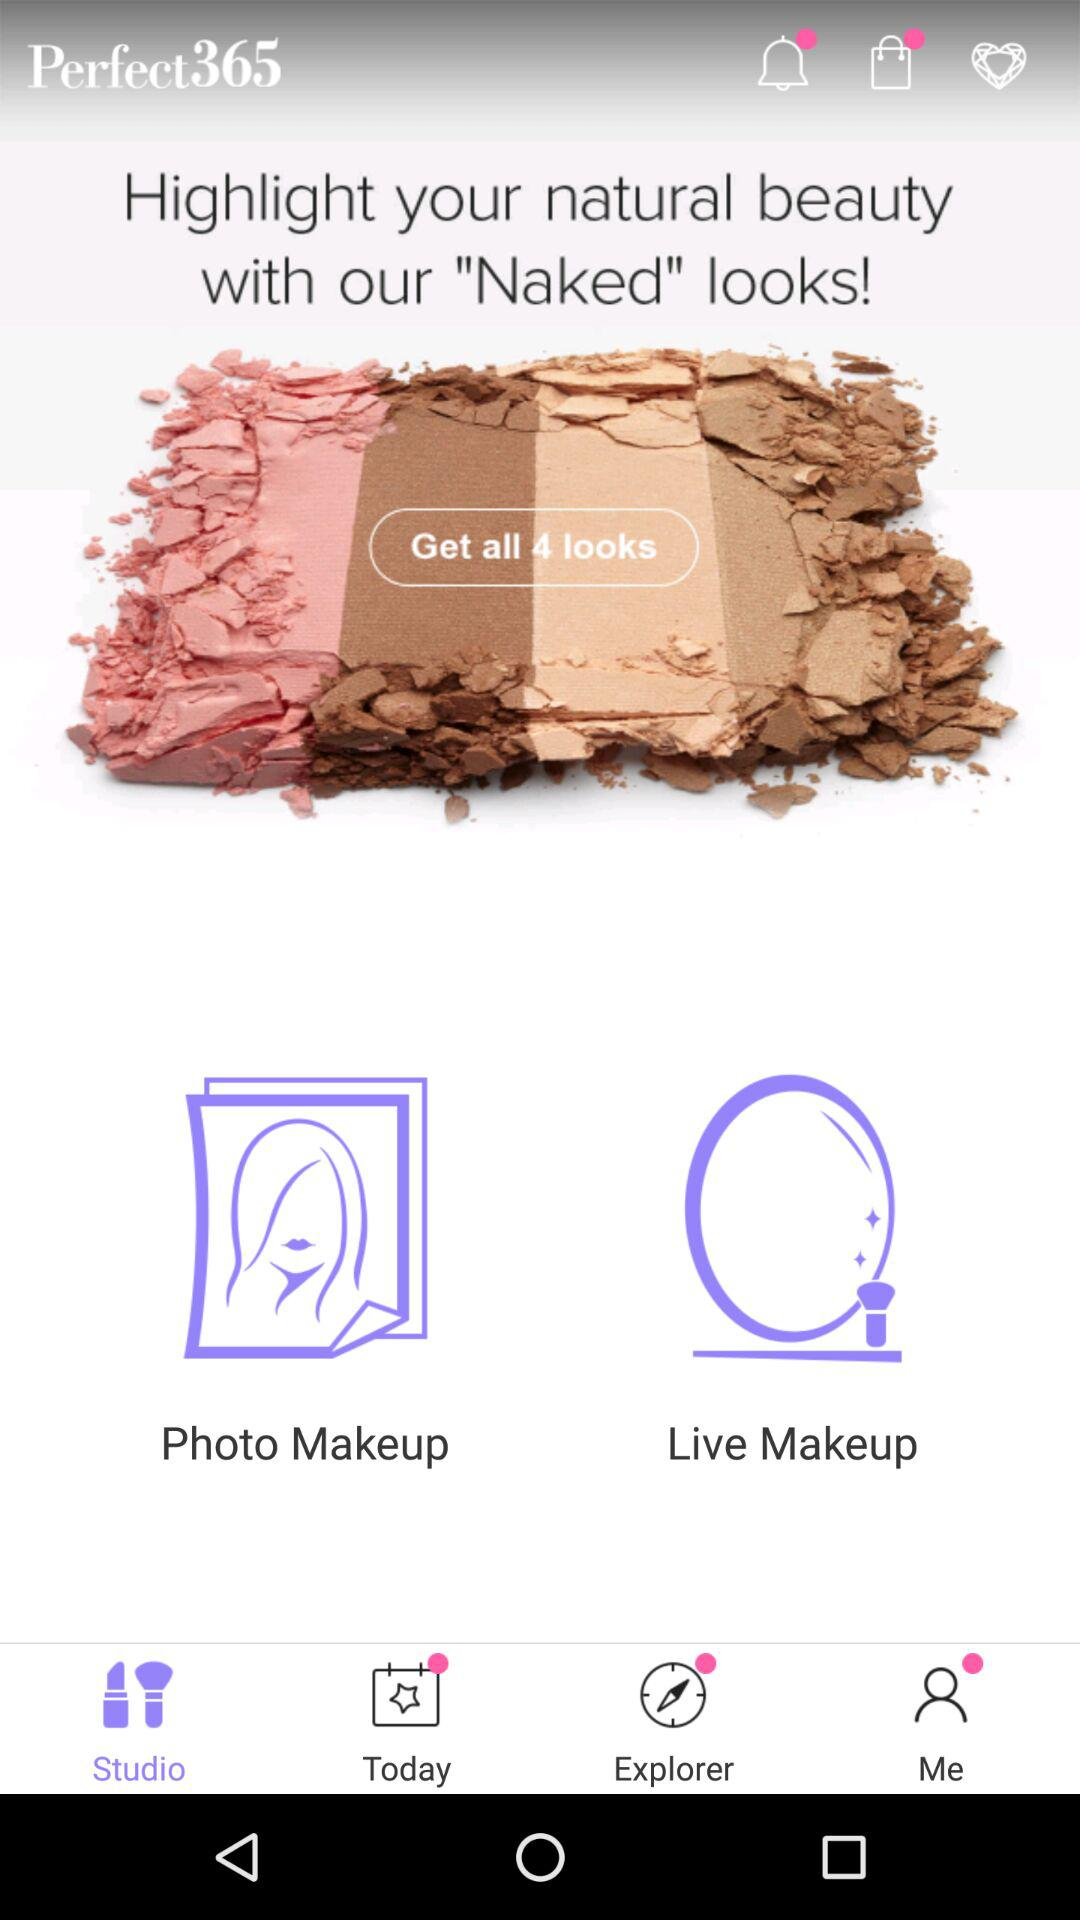How many more looks can you get with the Perfect365 app than the Live Makeup app?
Answer the question using a single word or phrase. 3 